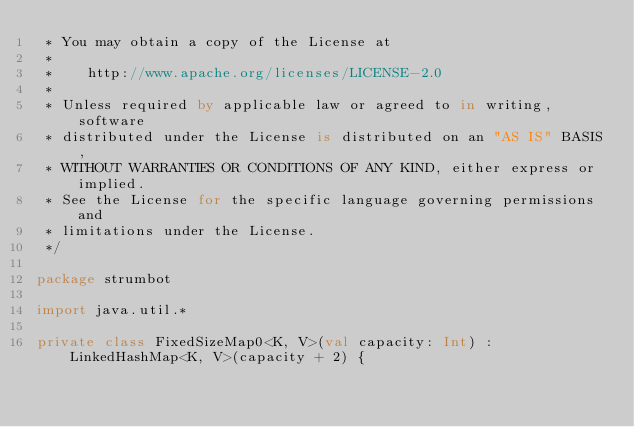Convert code to text. <code><loc_0><loc_0><loc_500><loc_500><_Kotlin_> * You may obtain a copy of the License at
 *
 *    http://www.apache.org/licenses/LICENSE-2.0
 *
 * Unless required by applicable law or agreed to in writing, software
 * distributed under the License is distributed on an "AS IS" BASIS,
 * WITHOUT WARRANTIES OR CONDITIONS OF ANY KIND, either express or implied.
 * See the License for the specific language governing permissions and
 * limitations under the License.
 */

package strumbot

import java.util.*

private class FixedSizeMap0<K, V>(val capacity: Int) : LinkedHashMap<K, V>(capacity + 2) {</code> 